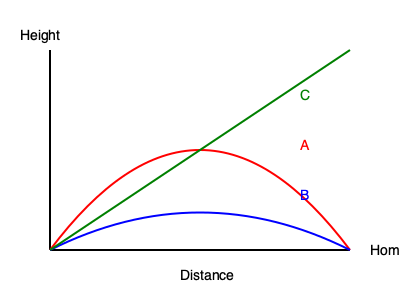As a seasoned player, you're familiar with various pitch types. The diagram shows trajectories of three different pitches from the pitcher's mound to home plate. Which pitch type does the blue trajectory (B) most likely represent? To identify the pitch type represented by the blue trajectory (B), let's analyze each trajectory:

1. Red trajectory (A):
   - Shows a high arc
   - Drops sharply near the plate
   - Characteristic of a curveball

2. Blue trajectory (B):
   - Has a slight downward curve
   - Maintains a relatively consistent path
   - Typical of a slider or cutter

3. Green trajectory (C):
   - Straight line from pitcher to plate
   - No curve or break
   - Represents a fastball

The blue trajectory (B) shows a slight, late break that's consistent with a slider. Sliders have a more subtle movement compared to curveballs and maintain velocity better than changeups. This pitch is designed to look like a fastball out of the hand but breaks laterally and down as it approaches the plate.

Given your experience as a pro player, you'd recognize this subtle movement as a classic slider trajectory. It's a pitch that requires precise grip and release to achieve the desired late break, making it an effective weapon against both right-handed and left-handed batters.
Answer: Slider 